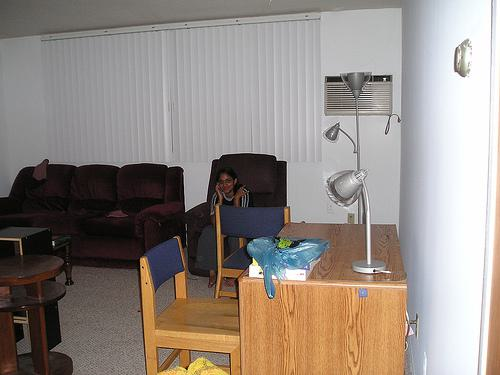How many chairs are there in the image? Upon closer inspection of the image, there seem to be at least two chairs visible. One chair is placed near the center with a blue item on it, and another is partly visible at the edge of the image to the left. 